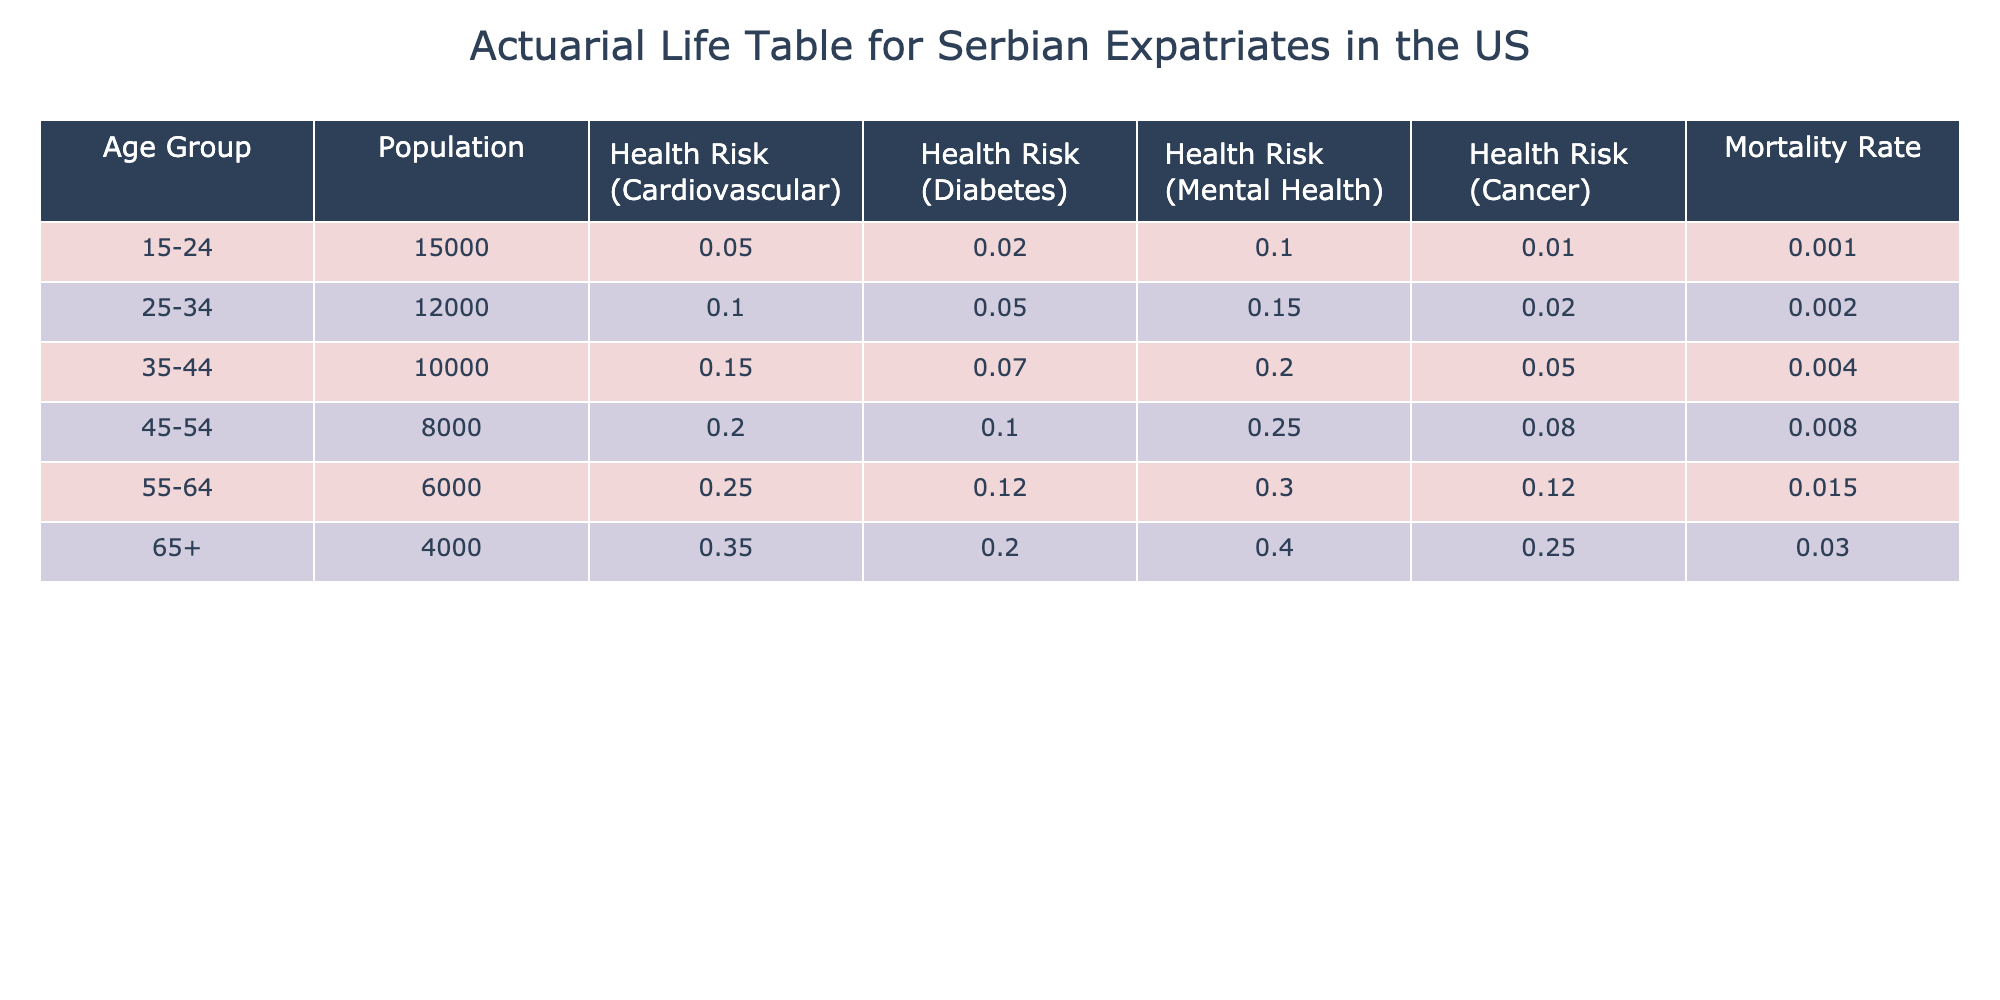What is the Health Risk for Diabetes in the Age Group 25-34? According to the table, the health risk for diabetes in the age group 25-34 is listed directly under the "Health Risk (Diabetes)" column, where the percentage is specified as 0.05.
Answer: 0.05 Which age group has the highest Mortality Rate? By inspecting the "Mortality Rate" column, the highest value is found in the age group 65+, where the mortality rate is 0.030.
Answer: 65+ What is the total population of Serbian expatriates aged 45-54? The table provides the population figure directly in the corresponding row under "Population" for the age group 45-54, which is recorded as 8000.
Answer: 8000 Is the Health Risk for Mental Health higher in the age group 55-64 than in the age group 35-44? The health risk percentages for mental health are 0.30 for age group 55-64 and 0.20 for age group 35-44. Since 0.30 > 0.20, the statement is true.
Answer: Yes What is the average Health Risk (Cancer) for all age groups? To find the average health risk for cancer, sum the values for the "Health Risk (Cancer)" column (0.01 + 0.02 + 0.05 + 0.08 + 0.12 + 0.25 = 0.53) and divide by the number of age groups (6), which gives 0.53 / 6 ≈ 0.0883.
Answer: Approximately 0.0883 Which age group has the lowest Health Risk for Cardiovascular issues? Reviewing the "Health Risk (Cardiovascular)" column, the lowest value can be found in the age group 15-24 at 0.05.
Answer: 15-24 What is the difference in Health Risks (Cancer) between the age groups 45-54 and 35-44? To find this difference, subtract the cancer health risk of age group 35-44 (0.05) from that of 45-54 (0.08), which results in 0.08 - 0.05 = 0.03.
Answer: 0.03 Do Serbian expatriates in the age group 55-64 have a lower Health Risk for Diabetes than those in the age group 45-54? The health risk for diabetes in the age group 55-64 is 0.12, while for age group 45-54 it is 0.10. Since 0.12 is greater than 0.10, the statement is false.
Answer: No What is the population of Serbian expatriates with the highest Health Risk for Mental Health? The highest health risk for mental health can be found in the age group 65+, and the corresponding population for this group is 4000.
Answer: 4000 